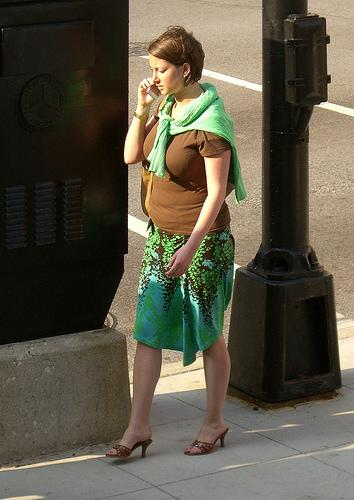What is the woman doing with her cell phone? The woman is holding her cell phone to her ear and talking on it while walking on the sidewalk. List all the objects related to the woman's appearance in the image. Green sweater, brown shoes, green and brown skirt, brown shirt, earring, cell phone, short hair, watch, and red nail polish. Describe the colors and patterns of the woman's clothes. The woman is wearing a solid brown shirt, a skirt with a green and brown print, and a green sweater tied around her shoulders. Provide a description of the woman's outfit in the image. The woman is wearing a brown shirt, a green and brown skirt, a green sweater tied around her shoulders, and brown high heels. She also has an earring and a watch on her left wrist. Identify the objects positioned around the woman on the sidewalk. There is a black traffic signal, sunlight reflecting on the concrete, a large black metal post, a white line painted on the roadway, and a concrete corner. Provide a description of the woman's hairstyle and accessories. The woman has short, tousled brown hair, and she is wearing an earring and a watch. What is the setting and location where the woman is walking? The woman is walking on a white concrete tiled sidewalk near a black traffic signal and a white line painted on the roadway. What type of shoes is the woman wearing, and what color are they? The woman is wearing brown, toeless high heels with a heel. Explain the woman's overall appearance and expression in the image. The woman has a casual and confident appearance with her short, tousled hair, stylish outfit, and talking on her cell phone while walking. What is the main activity happening in the image? A lady with short brown hair is walking on a sidewalk while talking on a cell phone. Identify the object at coordinates X:251 Y:0 with Width:88 Height:88. It's a large black metal post. What is the woman doing with the cell phone? The woman is talking on the cell phone. Describe the main objects in the image. There is a lady with short brown hair, a green sweater, brown shirt, green and brown skirt, brown shoes, an earring, a watch, and a cell phone. Is the woman wearing a toenail polish? If yes, what color? Yes, the woman is wearing red toenail polish. Is there any anomaly present in the image, like something unusual or out of place? No, there is no significant anomaly detected. Translate any text visible in the image or include "No text" if none. No text. What is on the woman's head? The woman has short brown hair on her head. What hairstyle does the woman have? The woman has short, tousled brown hair. What is the texture of the sidewalk? The sidewalk is white concrete tiled. List a few actions or interactions happening in the image. Lady talking on cell phone, walking on sidewalk, holding cell phone, wearing a watch. What type of shoes the lady is wearing? The lady is wearing brown high heels. Identify the main segments in the image. Lady, green sweater, brown shirt, green and brown skirt, brown high heels, earring, cell phone, watch. Find the object at position X:214 Y:62 with Width:41 Height:41. It's a white stripe in the parking lot. Does the image have good quality? Yes, the image has good quality. Identify the object located at position X:180 Y:72 with Width:9 Height:9. It's the earring in the lady's ear. What is the color of the woman's sweater? The sweater is green. What is the sentiment of the image? Neutral sentiment. 